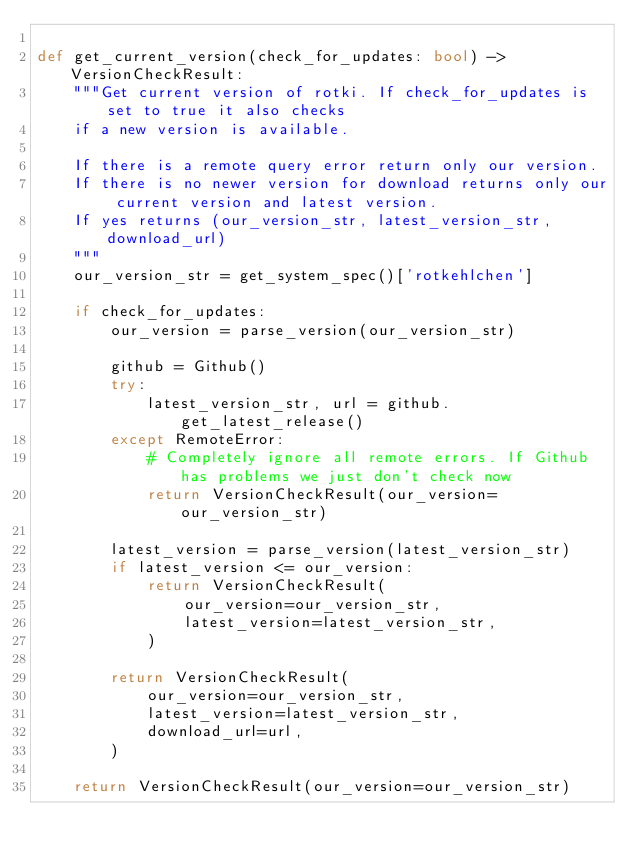Convert code to text. <code><loc_0><loc_0><loc_500><loc_500><_Python_>
def get_current_version(check_for_updates: bool) -> VersionCheckResult:
    """Get current version of rotki. If check_for_updates is set to true it also checks
    if a new version is available.

    If there is a remote query error return only our version.
    If there is no newer version for download returns only our current version and latest version.
    If yes returns (our_version_str, latest_version_str, download_url)
    """
    our_version_str = get_system_spec()['rotkehlchen']

    if check_for_updates:
        our_version = parse_version(our_version_str)

        github = Github()
        try:
            latest_version_str, url = github.get_latest_release()
        except RemoteError:
            # Completely ignore all remote errors. If Github has problems we just don't check now
            return VersionCheckResult(our_version=our_version_str)

        latest_version = parse_version(latest_version_str)
        if latest_version <= our_version:
            return VersionCheckResult(
                our_version=our_version_str,
                latest_version=latest_version_str,
            )

        return VersionCheckResult(
            our_version=our_version_str,
            latest_version=latest_version_str,
            download_url=url,
        )

    return VersionCheckResult(our_version=our_version_str)
</code> 